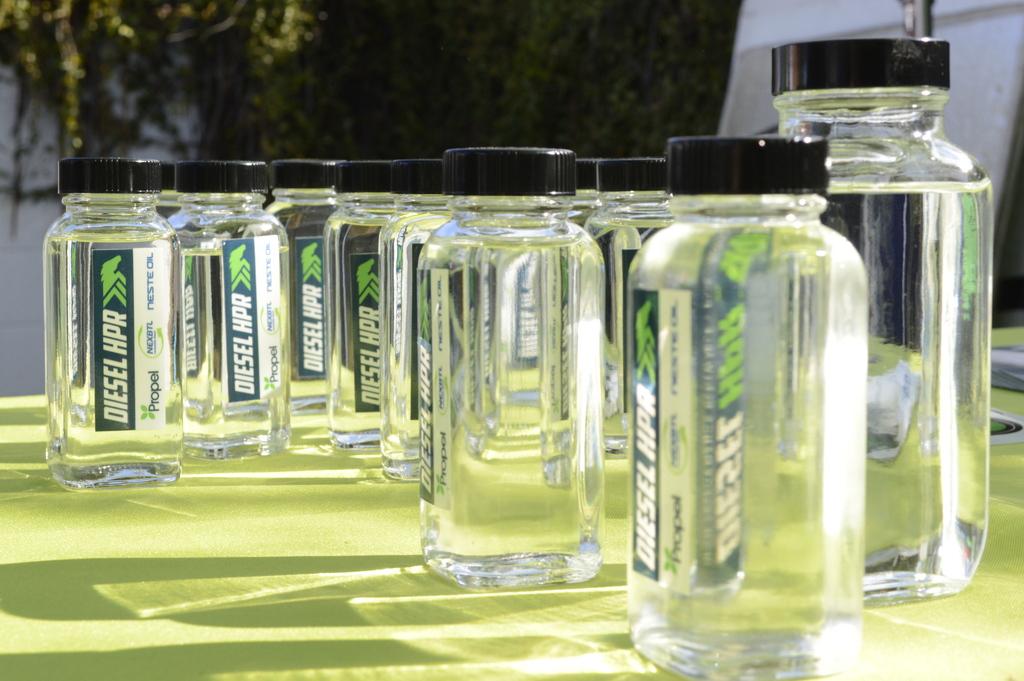What company made the jars?
Your response must be concise. Diesel hpr. 